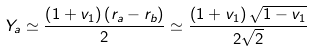<formula> <loc_0><loc_0><loc_500><loc_500>Y _ { a } \simeq \frac { \left ( 1 + v _ { 1 } \right ) \left ( r _ { a } - r _ { b } \right ) } { 2 } \simeq \frac { \left ( 1 + v _ { 1 } \right ) \sqrt { 1 - v _ { 1 } } } { 2 \sqrt { 2 } }</formula> 